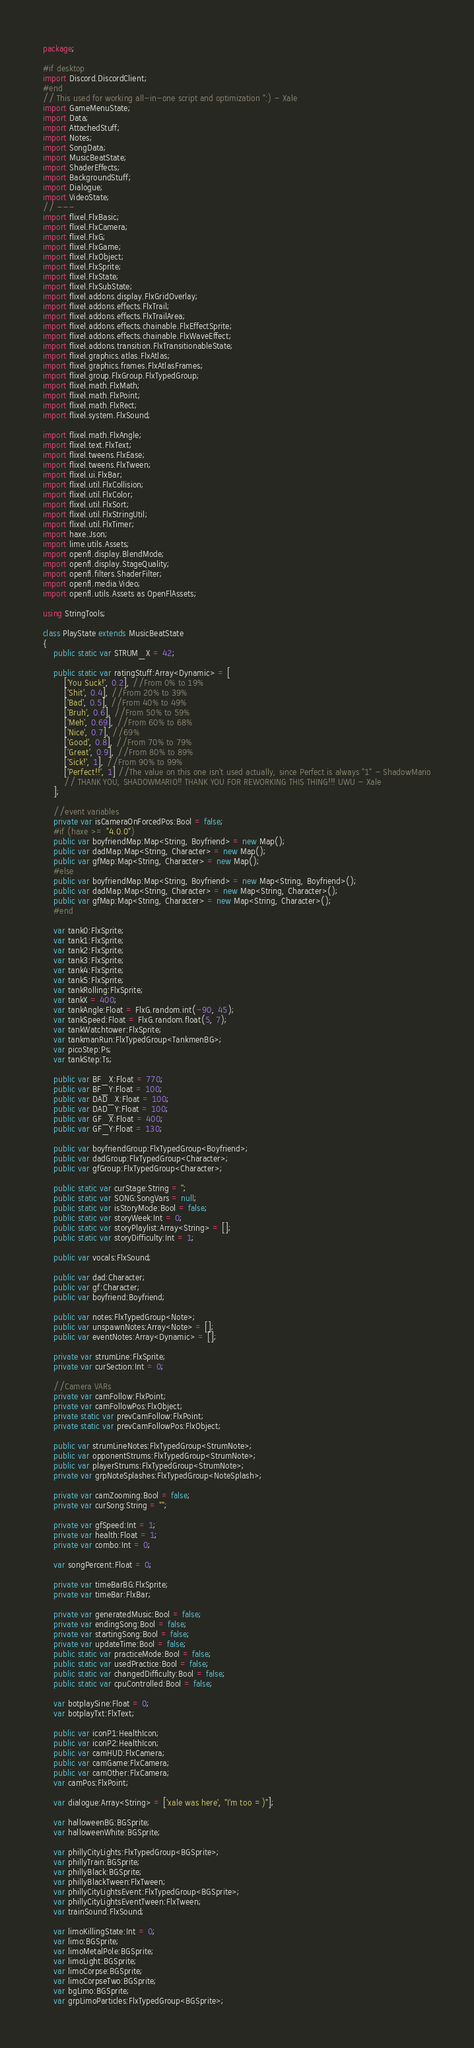<code> <loc_0><loc_0><loc_500><loc_500><_Haxe_>package;

#if desktop
import Discord.DiscordClient;
#end
// This used for working all-in-one script and optimization ":) - Xale
import GameMenuState;
import Data;
import AttachedStuff;
import Notes;
import SongData;
import MusicBeatState;
import ShaderEffects;
import BackgroundStuff;
import Dialogue;
import VideoState;
// ---
import flixel.FlxBasic;
import flixel.FlxCamera;
import flixel.FlxG;
import flixel.FlxGame;
import flixel.FlxObject;
import flixel.FlxSprite;
import flixel.FlxState;
import flixel.FlxSubState;
import flixel.addons.display.FlxGridOverlay;
import flixel.addons.effects.FlxTrail;
import flixel.addons.effects.FlxTrailArea;
import flixel.addons.effects.chainable.FlxEffectSprite;
import flixel.addons.effects.chainable.FlxWaveEffect;
import flixel.addons.transition.FlxTransitionableState;
import flixel.graphics.atlas.FlxAtlas;
import flixel.graphics.frames.FlxAtlasFrames;
import flixel.group.FlxGroup.FlxTypedGroup;
import flixel.math.FlxMath;
import flixel.math.FlxPoint;
import flixel.math.FlxRect;
import flixel.system.FlxSound;

import flixel.math.FlxAngle;
import flixel.text.FlxText;
import flixel.tweens.FlxEase;
import flixel.tweens.FlxTween;
import flixel.ui.FlxBar;
import flixel.util.FlxCollision;
import flixel.util.FlxColor;
import flixel.util.FlxSort;
import flixel.util.FlxStringUtil;
import flixel.util.FlxTimer;
import haxe.Json;
import lime.utils.Assets;
import openfl.display.BlendMode;
import openfl.display.StageQuality;
import openfl.filters.ShaderFilter;
import openfl.media.Video;
import openfl.utils.Assets as OpenFlAssets;

using StringTools;

class PlayState extends MusicBeatState
{
	public static var STRUM_X = 42;

	public static var ratingStuff:Array<Dynamic> = [
		['You Suck!', 0.2], //From 0% to 19%
		['Shit', 0.4], //From 20% to 39%
		['Bad', 0.5], //From 40% to 49%
		['Bruh', 0.6], //From 50% to 59%
		['Meh', 0.69], //From 60% to 68%
		['Nice', 0.7], //69%
		['Good', 0.8], //From 70% to 79%
		['Great', 0.9], //From 80% to 89%
		['Sick!', 1], //From 90% to 99%
		['Perfect!!', 1] //The value on this one isn't used actually, since Perfect is always "1" - ShadowMario
		// THANK YOU, SHADOWMARIO!! THANK YOU FOR REWORKING THIS THING!!! UWU - Xale
	]; 

	//event variables
	private var isCameraOnForcedPos:Bool = false;
	#if (haxe >= "4.0.0")
	public var boyfriendMap:Map<String, Boyfriend> = new Map();
	public var dadMap:Map<String, Character> = new Map();
	public var gfMap:Map<String, Character> = new Map();
	#else
	public var boyfriendMap:Map<String, Boyfriend> = new Map<String, Boyfriend>();
	public var dadMap:Map<String, Character> = new Map<String, Character>();
	public var gfMap:Map<String, Character> = new Map<String, Character>();
	#end

	var tank0:FlxSprite;
	var tank1:FlxSprite;
	var tank2:FlxSprite;
	var tank3:FlxSprite;
	var tank4:FlxSprite;
	var tank5:FlxSprite;
	var tankRolling:FlxSprite;
	var tankX = 400;
	var tankAngle:Float = FlxG.random.int(-90, 45);
	var tankSpeed:Float = FlxG.random.float(5, 7);
	var tankWatchtower:FlxSprite;
	var tankmanRun:FlxTypedGroup<TankmenBG>;
	var picoStep:Ps;
	var tankStep:Ts;

	public var BF_X:Float = 770;
	public var BF_Y:Float = 100;
	public var DAD_X:Float = 100;
	public var DAD_Y:Float = 100;
	public var GF_X:Float = 400;
	public var GF_Y:Float = 130;

	public var boyfriendGroup:FlxTypedGroup<Boyfriend>;
	public var dadGroup:FlxTypedGroup<Character>;
	public var gfGroup:FlxTypedGroup<Character>;

	public static var curStage:String = '';
	public static var SONG:SongVars = null;
	public static var isStoryMode:Bool = false;
	public static var storyWeek:Int = 0;
	public static var storyPlaylist:Array<String> = [];
	public static var storyDifficulty:Int = 1;

	public var vocals:FlxSound;

	public var dad:Character;
	public var gf:Character;
	public var boyfriend:Boyfriend;

	public var notes:FlxTypedGroup<Note>;
	public var unspawnNotes:Array<Note> = [];
	public var eventNotes:Array<Dynamic> = [];

	private var strumLine:FlxSprite;
	private var curSection:Int = 0;

	//Camera VARs
	private var camFollow:FlxPoint;
	private var camFollowPos:FlxObject;
	private static var prevCamFollow:FlxPoint;
	private static var prevCamFollowPos:FlxObject;

	public var strumLineNotes:FlxTypedGroup<StrumNote>;
	public var opponentStrums:FlxTypedGroup<StrumNote>;
	public var playerStrums:FlxTypedGroup<StrumNote>;
	private var grpNoteSplashes:FlxTypedGroup<NoteSplash>;

	private var camZooming:Bool = false;
	private var curSong:String = "";

	private var gfSpeed:Int = 1;
	private var health:Float = 1;
	private var combo:Int = 0;

	var songPercent:Float = 0;

	private var timeBarBG:FlxSprite;
	private var timeBar:FlxBar;

	private var generatedMusic:Bool = false;
	private var endingSong:Bool = false;
	private var startingSong:Bool = false;
	private var updateTime:Bool = false;
	public static var practiceMode:Bool = false;
	public static var usedPractice:Bool = false;
	public static var changedDifficulty:Bool = false;
	public static var cpuControlled:Bool = false;

	var botplaySine:Float = 0;
	var botplayTxt:FlxText;

	public var iconP1:HealthIcon;
	public var iconP2:HealthIcon;
	public var camHUD:FlxCamera;
	public var camGame:FlxCamera;
	public var camOther:FlxCamera;
	var camPos:FlxPoint;

	var dialogue:Array<String> = ['xale was here', "I'm too =)"];

	var halloweenBG:BGSprite;
	var halloweenWhite:BGSprite;

	var phillyCityLights:FlxTypedGroup<BGSprite>;
	var phillyTrain:BGSprite;
	var phillyBlack:BGSprite;
	var phillyBlackTween:FlxTween;
	var phillyCityLightsEvent:FlxTypedGroup<BGSprite>;
	var phillyCityLightsEventTween:FlxTween;
	var trainSound:FlxSound;

	var limoKillingState:Int = 0;
	var limo:BGSprite;
	var limoMetalPole:BGSprite;
	var limoLight:BGSprite;
	var limoCorpse:BGSprite;
	var limoCorpseTwo:BGSprite;
	var bgLimo:BGSprite;
	var grpLimoParticles:FlxTypedGroup<BGSprite>;</code> 